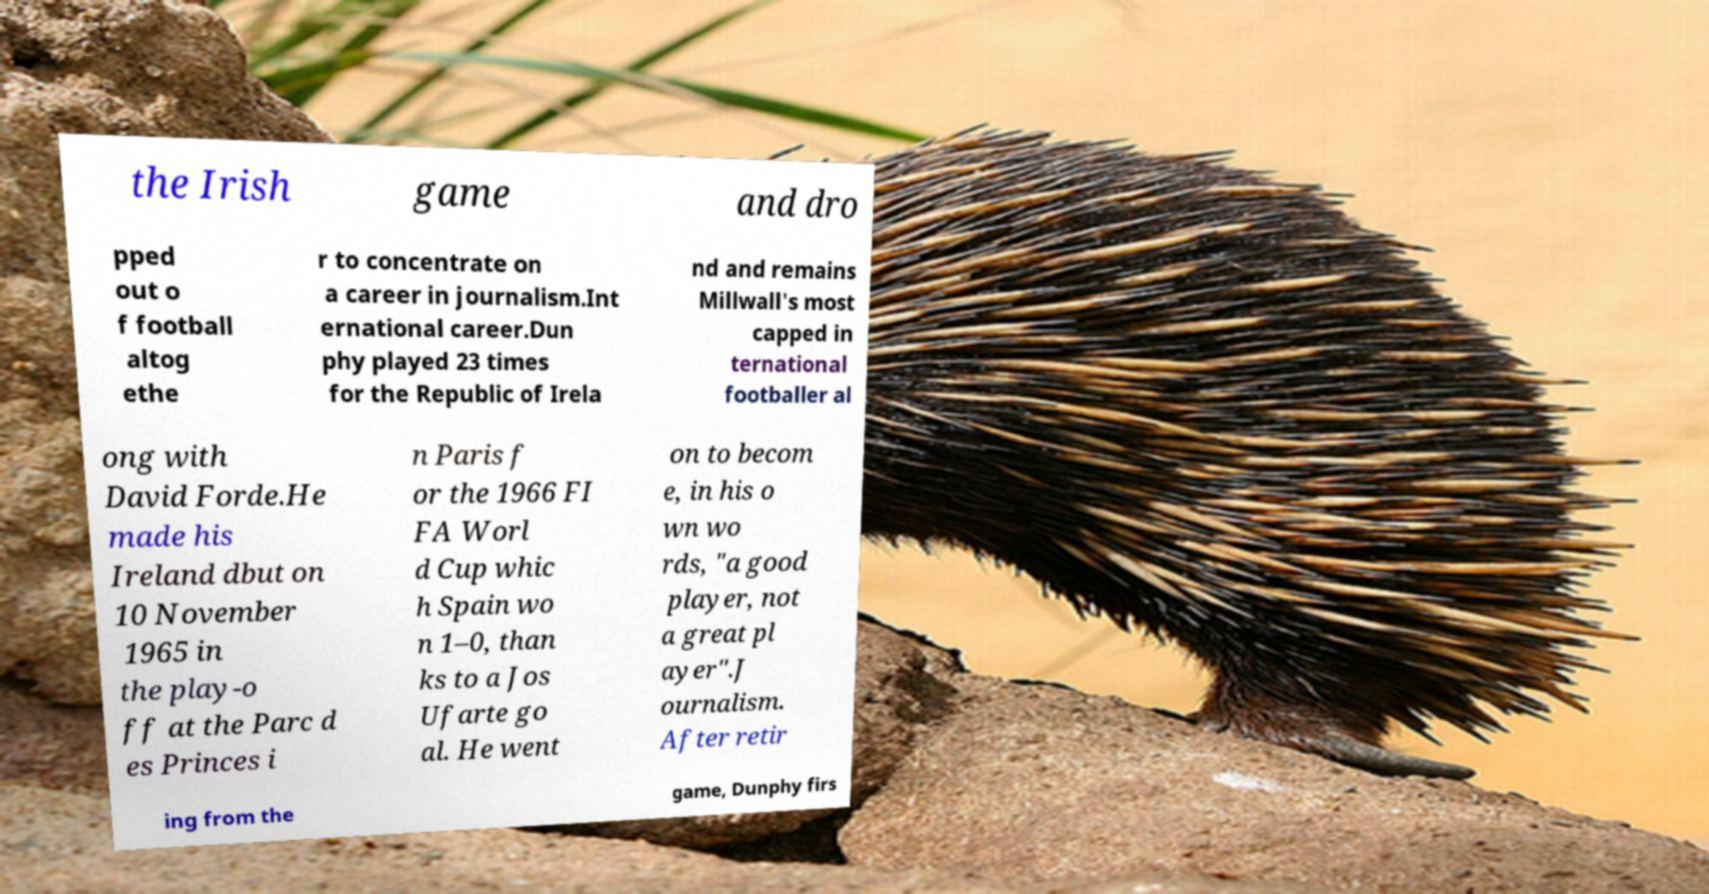Please identify and transcribe the text found in this image. the Irish game and dro pped out o f football altog ethe r to concentrate on a career in journalism.Int ernational career.Dun phy played 23 times for the Republic of Irela nd and remains Millwall's most capped in ternational footballer al ong with David Forde.He made his Ireland dbut on 10 November 1965 in the play-o ff at the Parc d es Princes i n Paris f or the 1966 FI FA Worl d Cup whic h Spain wo n 1–0, than ks to a Jos Ufarte go al. He went on to becom e, in his o wn wo rds, "a good player, not a great pl ayer".J ournalism. After retir ing from the game, Dunphy firs 